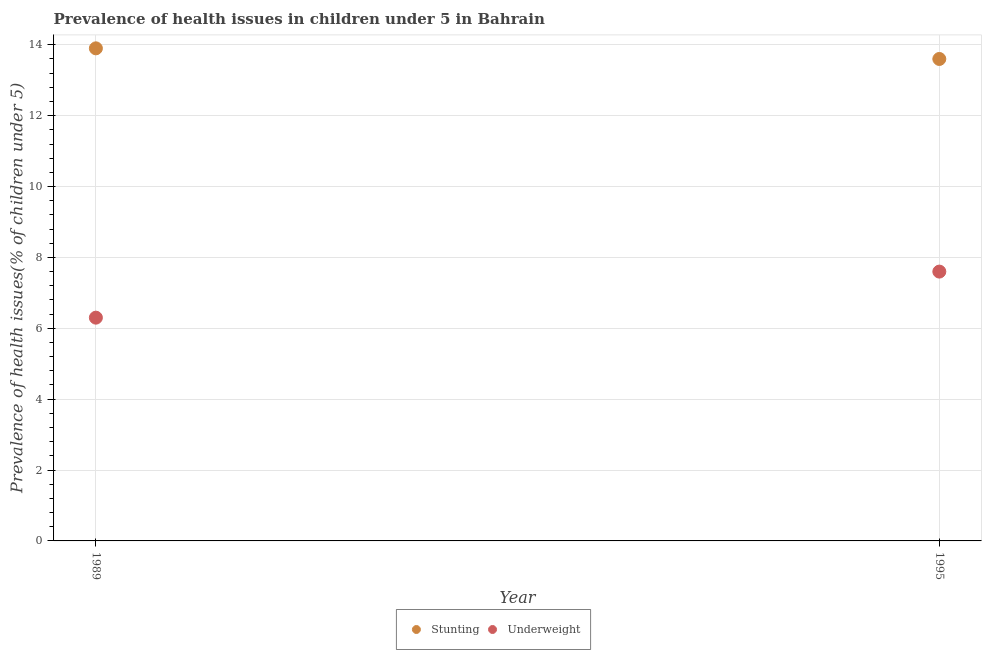What is the percentage of stunted children in 1989?
Keep it short and to the point. 13.9. Across all years, what is the maximum percentage of stunted children?
Offer a terse response. 13.9. Across all years, what is the minimum percentage of underweight children?
Keep it short and to the point. 6.3. In which year was the percentage of stunted children maximum?
Your answer should be compact. 1989. In which year was the percentage of underweight children minimum?
Make the answer very short. 1989. What is the total percentage of underweight children in the graph?
Provide a succinct answer. 13.9. What is the difference between the percentage of stunted children in 1989 and that in 1995?
Provide a short and direct response. 0.3. What is the difference between the percentage of underweight children in 1989 and the percentage of stunted children in 1995?
Make the answer very short. -7.3. What is the average percentage of underweight children per year?
Your answer should be very brief. 6.95. In the year 1989, what is the difference between the percentage of stunted children and percentage of underweight children?
Keep it short and to the point. 7.6. In how many years, is the percentage of underweight children greater than 4 %?
Give a very brief answer. 2. What is the ratio of the percentage of underweight children in 1989 to that in 1995?
Provide a succinct answer. 0.83. Is the percentage of stunted children in 1989 less than that in 1995?
Give a very brief answer. No. In how many years, is the percentage of stunted children greater than the average percentage of stunted children taken over all years?
Make the answer very short. 1. Is the percentage of underweight children strictly greater than the percentage of stunted children over the years?
Provide a short and direct response. No. How many dotlines are there?
Make the answer very short. 2. How many years are there in the graph?
Your response must be concise. 2. What is the difference between two consecutive major ticks on the Y-axis?
Offer a very short reply. 2. What is the title of the graph?
Your response must be concise. Prevalence of health issues in children under 5 in Bahrain. What is the label or title of the X-axis?
Keep it short and to the point. Year. What is the label or title of the Y-axis?
Make the answer very short. Prevalence of health issues(% of children under 5). What is the Prevalence of health issues(% of children under 5) of Stunting in 1989?
Offer a terse response. 13.9. What is the Prevalence of health issues(% of children under 5) of Underweight in 1989?
Provide a succinct answer. 6.3. What is the Prevalence of health issues(% of children under 5) of Stunting in 1995?
Give a very brief answer. 13.6. What is the Prevalence of health issues(% of children under 5) in Underweight in 1995?
Offer a terse response. 7.6. Across all years, what is the maximum Prevalence of health issues(% of children under 5) of Stunting?
Offer a terse response. 13.9. Across all years, what is the maximum Prevalence of health issues(% of children under 5) of Underweight?
Keep it short and to the point. 7.6. Across all years, what is the minimum Prevalence of health issues(% of children under 5) in Stunting?
Your response must be concise. 13.6. Across all years, what is the minimum Prevalence of health issues(% of children under 5) of Underweight?
Your answer should be compact. 6.3. What is the average Prevalence of health issues(% of children under 5) in Stunting per year?
Offer a terse response. 13.75. What is the average Prevalence of health issues(% of children under 5) of Underweight per year?
Your answer should be compact. 6.95. In the year 1989, what is the difference between the Prevalence of health issues(% of children under 5) of Stunting and Prevalence of health issues(% of children under 5) of Underweight?
Offer a very short reply. 7.6. In the year 1995, what is the difference between the Prevalence of health issues(% of children under 5) of Stunting and Prevalence of health issues(% of children under 5) of Underweight?
Provide a short and direct response. 6. What is the ratio of the Prevalence of health issues(% of children under 5) of Stunting in 1989 to that in 1995?
Provide a short and direct response. 1.02. What is the ratio of the Prevalence of health issues(% of children under 5) in Underweight in 1989 to that in 1995?
Provide a succinct answer. 0.83. What is the difference between the highest and the second highest Prevalence of health issues(% of children under 5) in Stunting?
Keep it short and to the point. 0.3. What is the difference between the highest and the lowest Prevalence of health issues(% of children under 5) of Underweight?
Provide a short and direct response. 1.3. 